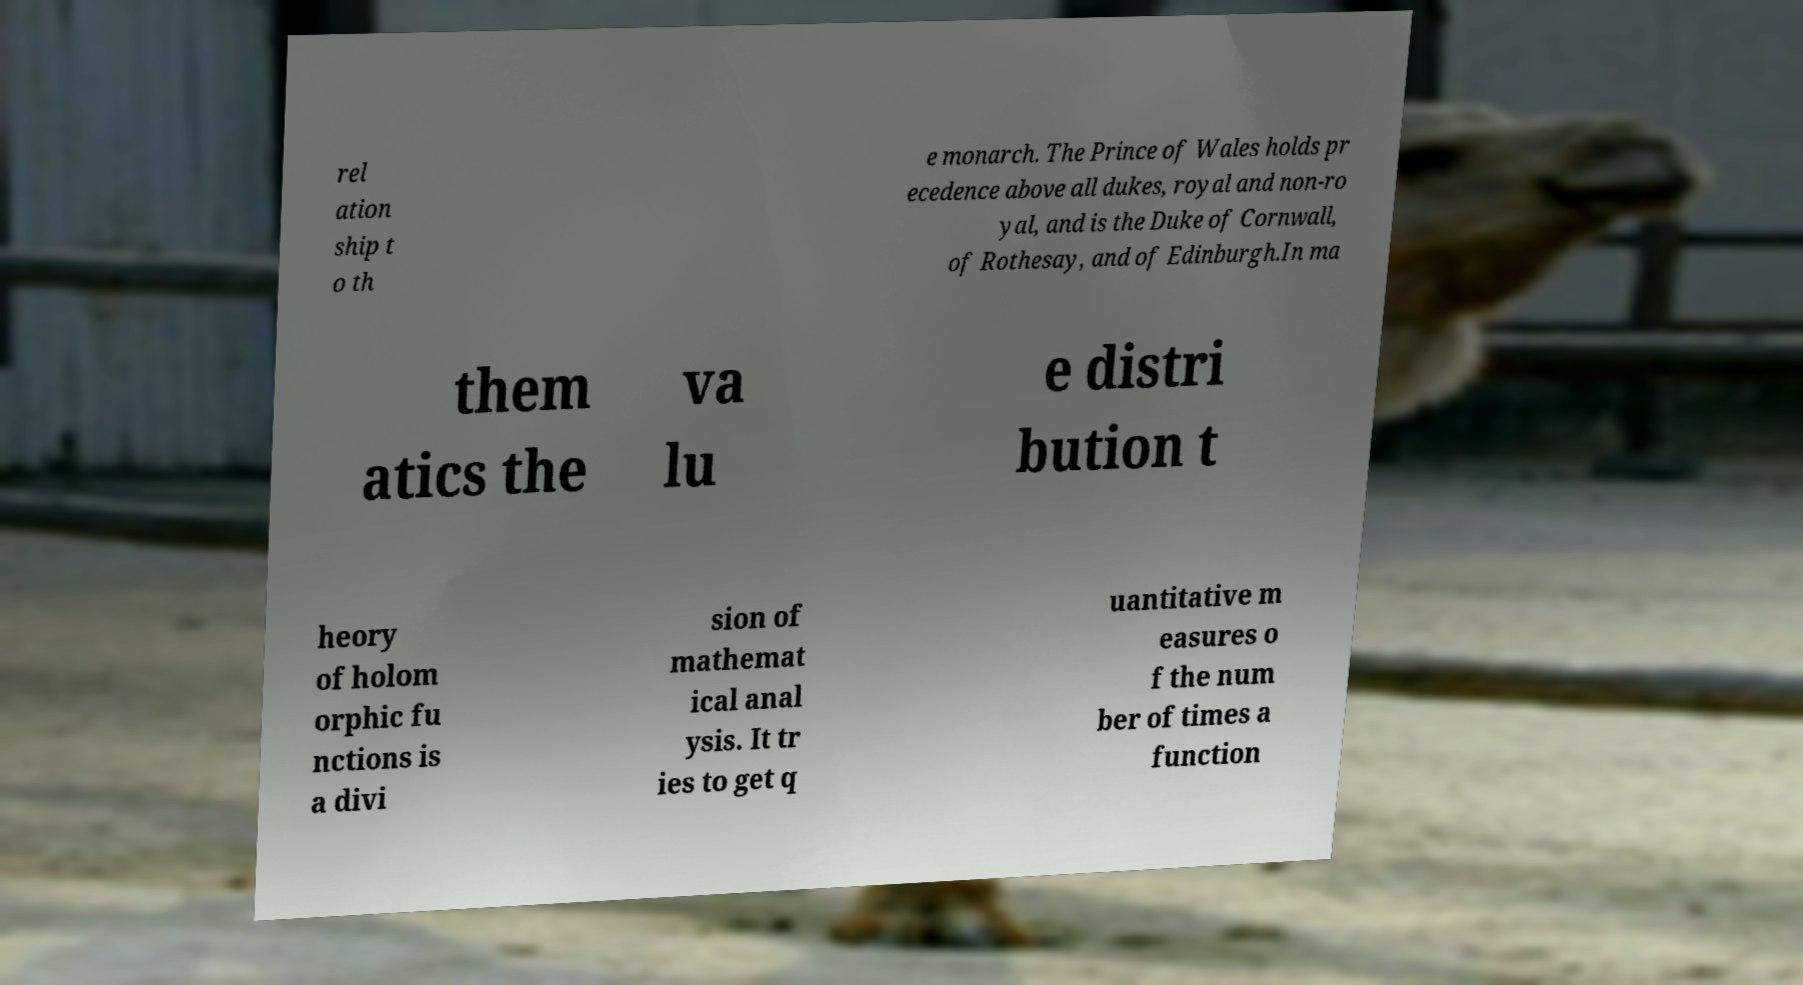Could you extract and type out the text from this image? rel ation ship t o th e monarch. The Prince of Wales holds pr ecedence above all dukes, royal and non-ro yal, and is the Duke of Cornwall, of Rothesay, and of Edinburgh.In ma them atics the va lu e distri bution t heory of holom orphic fu nctions is a divi sion of mathemat ical anal ysis. It tr ies to get q uantitative m easures o f the num ber of times a function 